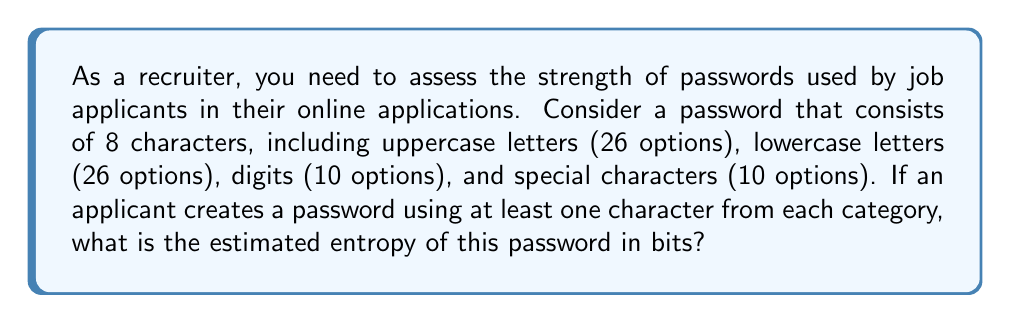Could you help me with this problem? To estimate the entropy of the password, we'll follow these steps:

1. Calculate the total number of possible characters:
   $26 + 26 + 10 + 10 = 72$ possible characters

2. For an 8-character password, the total number of possible combinations is:
   $72^8$

3. However, we need to ensure at least one character from each category. We can use the Inclusion-Exclusion Principle, but for simplicity, we'll use an approximation:
   $72^8 - (72^8 - 71^8)$

4. The entropy is calculated as the log base 2 of the number of possible combinations:

   $$\text{Entropy} = \log_2(72^8 - (72^8 - 71^8))$$

5. Simplify:
   $$\text{Entropy} = \log_2(72^8 - 72^8 + 71^8)$$
   $$\text{Entropy} = \log_2(71^8)$$

6. Using the logarithm property:
   $$\text{Entropy} = 8 \log_2(71)$$

7. Calculate:
   $$\text{Entropy} \approx 8 \times 6.1496 \approx 49.1968 \text{ bits}$$
Answer: 49.2 bits 